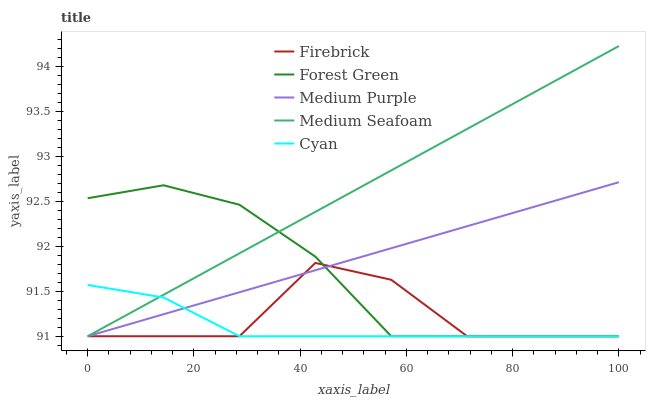Does Cyan have the minimum area under the curve?
Answer yes or no. Yes. Does Medium Seafoam have the maximum area under the curve?
Answer yes or no. Yes. Does Firebrick have the minimum area under the curve?
Answer yes or no. No. Does Firebrick have the maximum area under the curve?
Answer yes or no. No. Is Medium Purple the smoothest?
Answer yes or no. Yes. Is Firebrick the roughest?
Answer yes or no. Yes. Is Cyan the smoothest?
Answer yes or no. No. Is Cyan the roughest?
Answer yes or no. No. Does Medium Purple have the lowest value?
Answer yes or no. Yes. Does Medium Seafoam have the highest value?
Answer yes or no. Yes. Does Firebrick have the highest value?
Answer yes or no. No. Does Medium Seafoam intersect Medium Purple?
Answer yes or no. Yes. Is Medium Seafoam less than Medium Purple?
Answer yes or no. No. Is Medium Seafoam greater than Medium Purple?
Answer yes or no. No. 